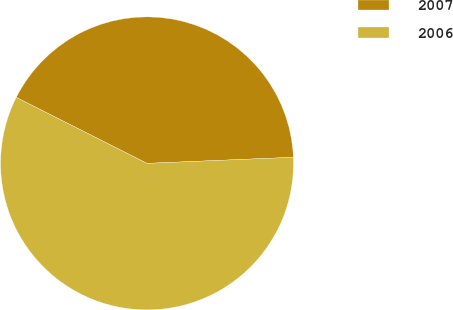Convert chart to OTSL. <chart><loc_0><loc_0><loc_500><loc_500><pie_chart><fcel>2007<fcel>2006<nl><fcel>41.9%<fcel>58.1%<nl></chart> 